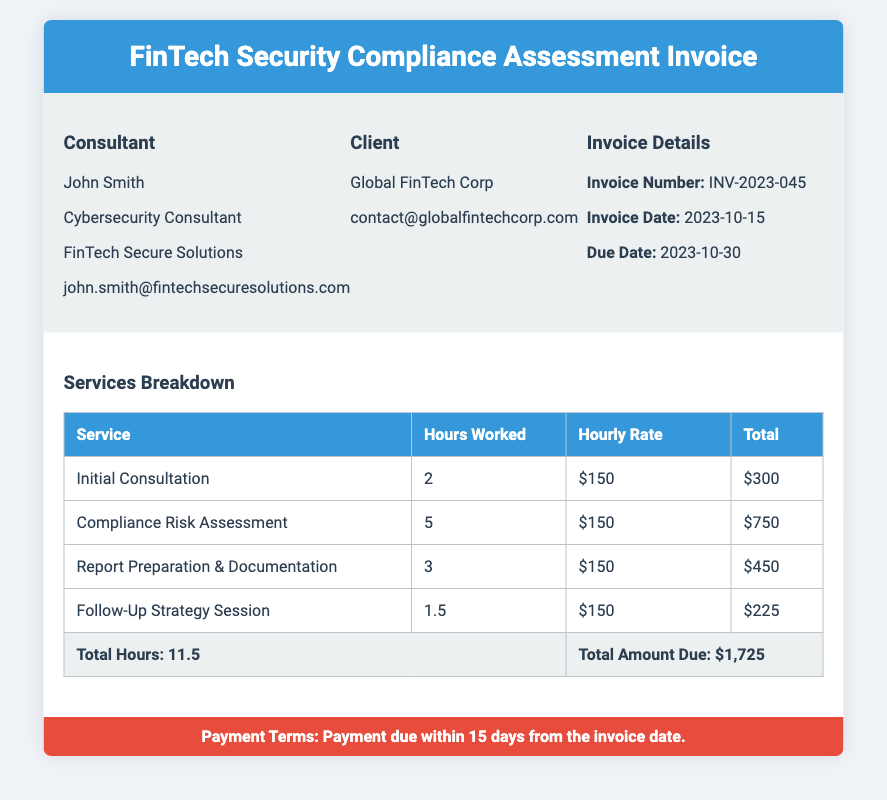What is the consultant's name? The consultant's name is mentioned at the top of the invoice under the Consultant section.
Answer: John Smith What is the total amount due? The total amount due is summarized at the bottom of the Services Breakdown table.
Answer: $1,725 How many hours were worked in total? The total hours worked are indicated in the total row of the Services Breakdown table.
Answer: 11.5 What is the due date for payment? The due date is located in the Invoice Details section of the document.
Answer: 2023-10-30 What is the hourly rate charged for services? The hourly rate is consistently stated in the Services Breakdown table for each service provided.
Answer: $150 What service was assessed for 5 hours? The specific service and corresponding hours are detailed in the Services Breakdown table.
Answer: Compliance Risk Assessment What is included in the invoice title? The title provides information about the nature of the document related to services offered.
Answer: FinTech Security Compliance Assessment Invoice What payment terms are specified? The payment terms are clearly stated in the designated section at the bottom of the invoice.
Answer: Payment due within 15 days from the invoice date 